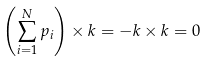Convert formula to latex. <formula><loc_0><loc_0><loc_500><loc_500>\left ( \sum _ { i = 1 } ^ { N } p _ { i } \right ) \times k = - k \times k = 0</formula> 